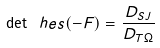<formula> <loc_0><loc_0><loc_500><loc_500>\det \ h e s ( - F ) = \frac { D _ { S J } } { D _ { T \Omega } }</formula> 